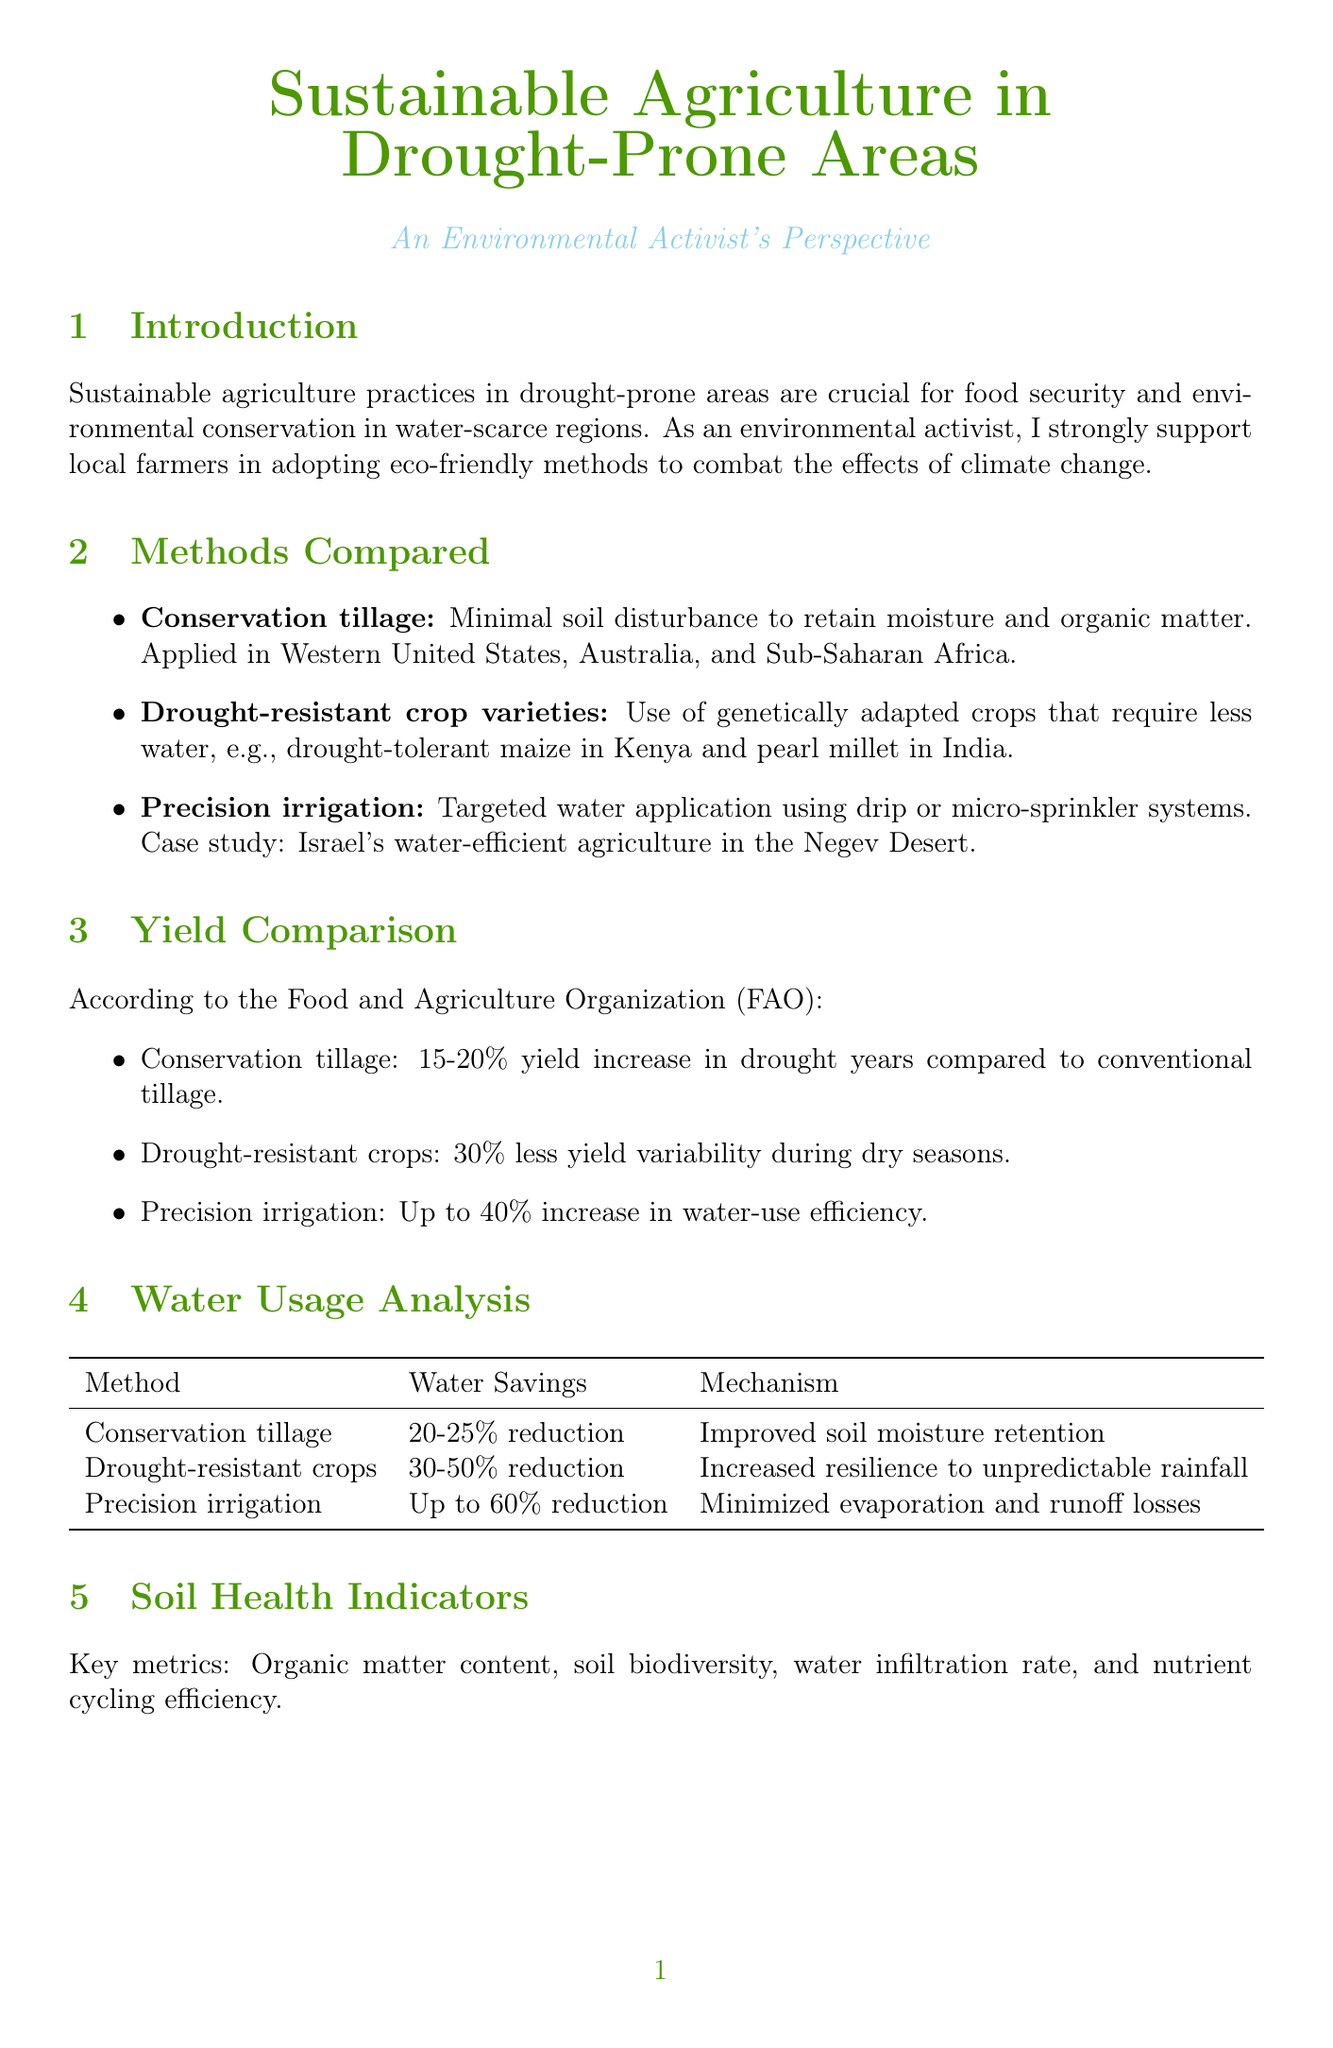What are some methods compared in the report? The report compares conservation tillage, drought-resistant crop varieties, and precision irrigation as methods for sustainable agriculture.
Answer: conservation tillage, drought-resistant crop varieties, precision irrigation What is the yield increase from conservation tillage in drought years? The yield increase from conservation tillage in drought years compared to conventional tillage is stated in the document as 15-20%.
Answer: 15-20% What is the water savings percentage for precision irrigation? The report indicates that precision irrigation can achieve up to 60% reduction in water use, which directly answers the question.
Answer: up to 60% Which region applies conservation tillage? The regions mentioned in the document where conservation tillage is applied include the Western United States, Australia, and Sub-Saharan Africa.
Answer: Western United States, Australia, Sub-Saharan Africa What is a key finding in the conclusion section? The conclusion section highlights that sustainable practices significantly improve yields and water efficiency while enhancing soil health.
Answer: improve yields and water efficiency while enhancing soil health What did the case study in Rajasthan, India achieve? The case study in Rajasthan combined rainwater harvesting with drought-resistant crops, resulting in a 40% increase in agricultural productivity and a 50% reduction in water usage.
Answer: 40% increase in agricultural productivity, 50% reduction in water usage What does the report recommend for policy advocacy? The document provides suggestions, including promoting government subsidies for water-efficient technologies and supporting research funding for climate-resilient agriculture.
Answer: Promote government subsidies for water-efficient technologies What metrics are used to assess soil health? The document lists organic matter content, soil biodiversity, water infiltration rate, and nutrient cycling efficiency as key metrics for soil health.
Answer: Organic matter content, soil biodiversity, water infiltration rate, nutrient cycling efficiency What is the importance of sustainable agriculture practices according to the introduction? The introduction states that sustainable agriculture practices are crucial for food security and environmental conservation in water-scarce regions.
Answer: food security and environmental conservation in water-scarce regions 